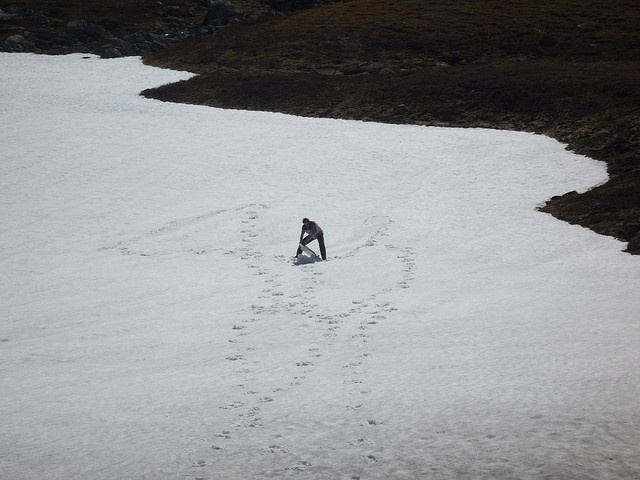Describe the objects in this image and their specific colors. I can see people in black, gray, lightgray, and darkgray tones and snowboard in black, gray, and darkgray tones in this image. 